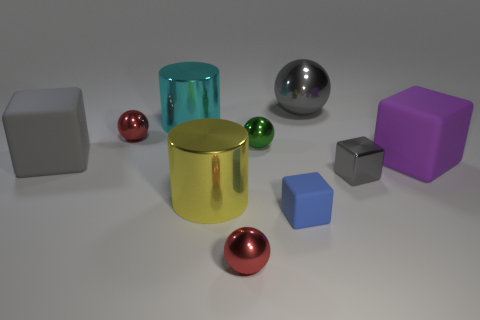Subtract all gray balls. How many gray cubes are left? 2 Subtract all big spheres. How many spheres are left? 3 Subtract all blue blocks. How many blocks are left? 3 Subtract all blocks. How many objects are left? 6 Add 5 large yellow shiny cylinders. How many large yellow shiny cylinders are left? 6 Add 4 big objects. How many big objects exist? 9 Subtract 0 cyan balls. How many objects are left? 10 Subtract all cyan blocks. Subtract all brown spheres. How many blocks are left? 4 Subtract all cyan cylinders. Subtract all big metallic balls. How many objects are left? 8 